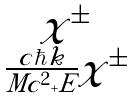Convert formula to latex. <formula><loc_0><loc_0><loc_500><loc_500>\begin{matrix} \chi ^ { \pm } \\ \frac { c \hbar { k } } { M c ^ { 2 } + E } \chi ^ { \pm } \end{matrix}</formula> 